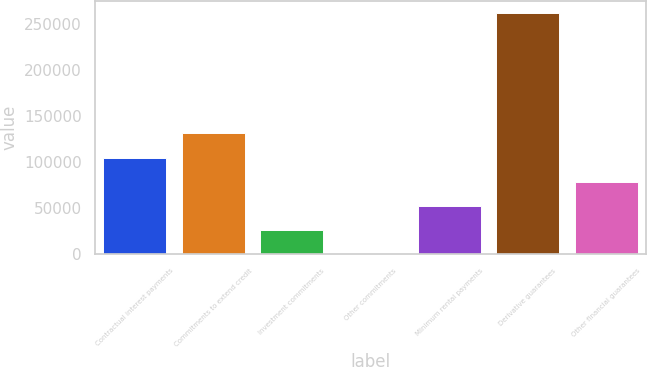<chart> <loc_0><loc_0><loc_500><loc_500><bar_chart><fcel>Contractual interest payments<fcel>Commitments to extend credit<fcel>Investment commitments<fcel>Other commitments<fcel>Minimum rental payments<fcel>Derivative guarantees<fcel>Other financial guarantees<nl><fcel>104790<fcel>130938<fcel>26347.6<fcel>200<fcel>52495.2<fcel>261676<fcel>78642.8<nl></chart> 